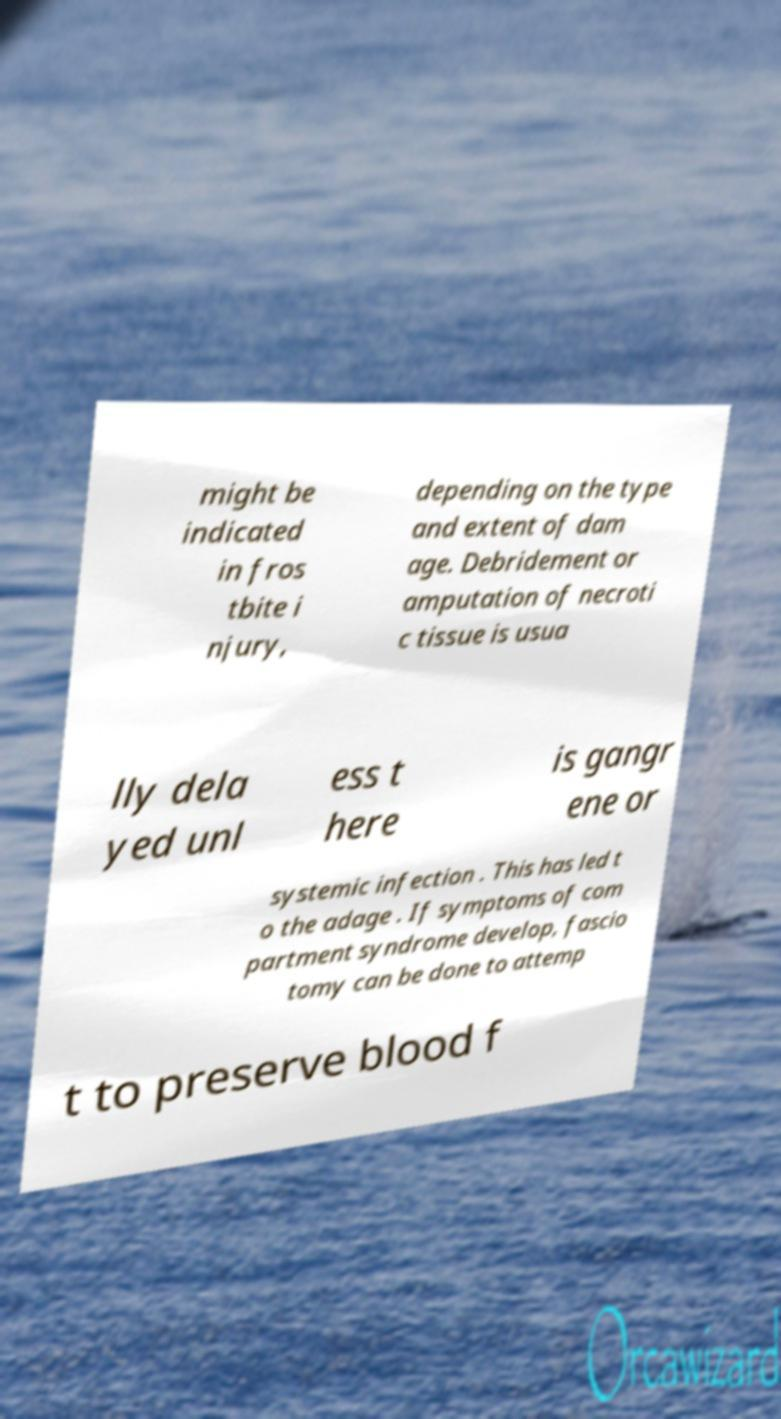Please read and relay the text visible in this image. What does it say? might be indicated in fros tbite i njury, depending on the type and extent of dam age. Debridement or amputation of necroti c tissue is usua lly dela yed unl ess t here is gangr ene or systemic infection . This has led t o the adage . If symptoms of com partment syndrome develop, fascio tomy can be done to attemp t to preserve blood f 